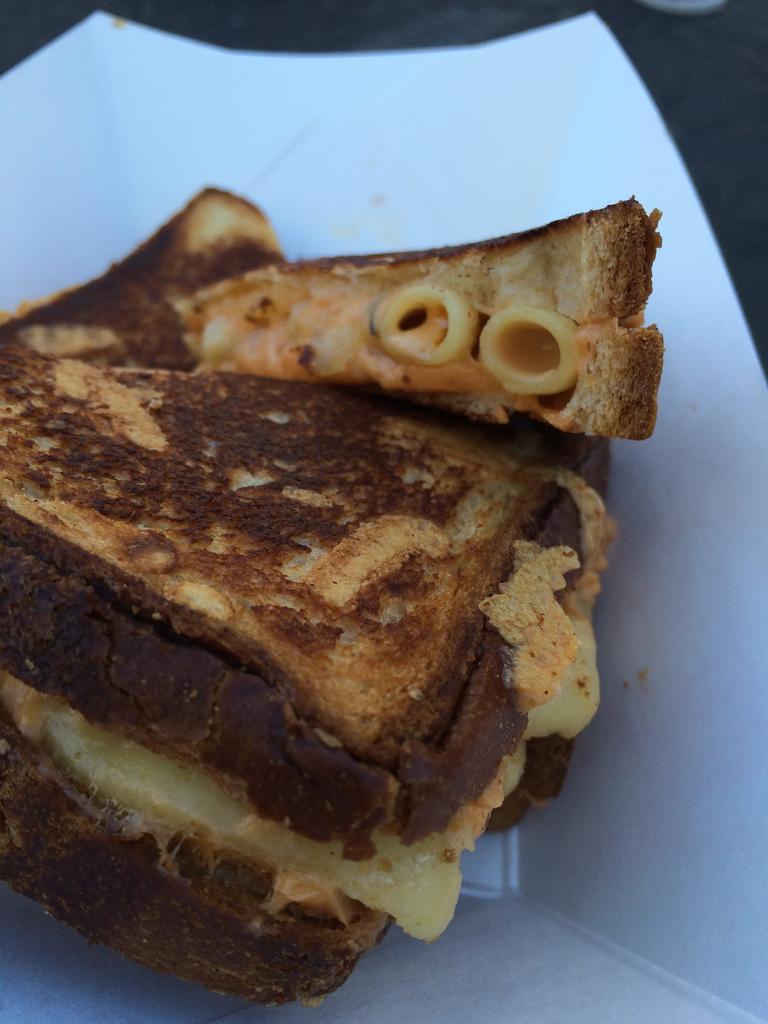Can you describe this image briefly? In this image we can see a sandwich in a which color plate. 